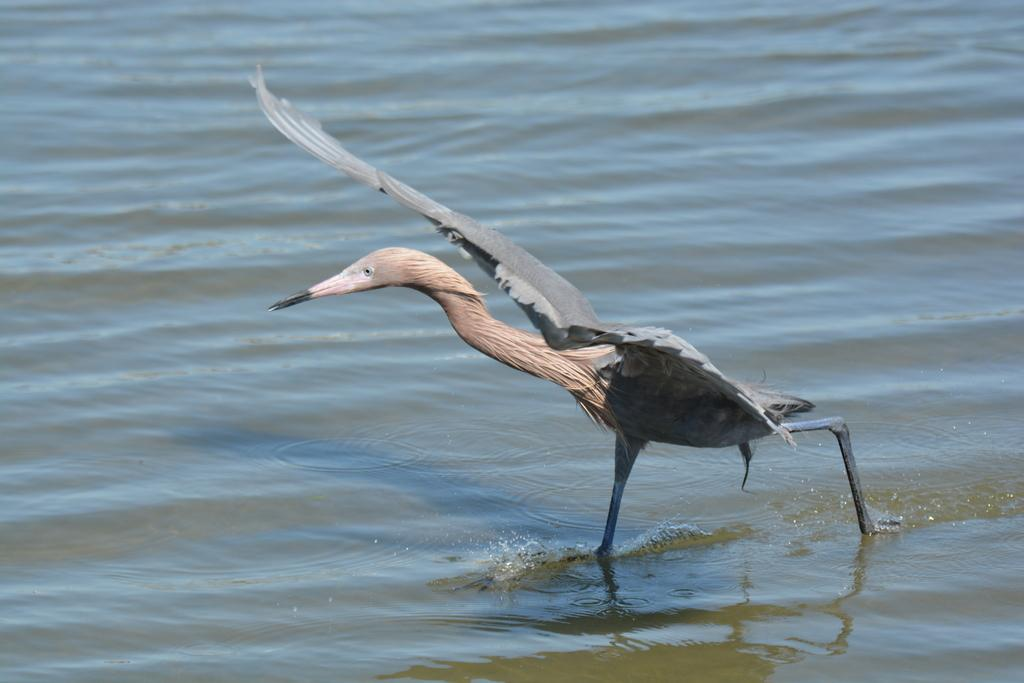What type of animal is in the image? There is a bird in the image. Can you identify the specific species of the bird? The bird is a great blue heron. What is the bird doing in the image? The bird is walking in the water. What type of honey is the bird collecting in the image? There is no honey present in the image, and the bird is not collecting anything. 